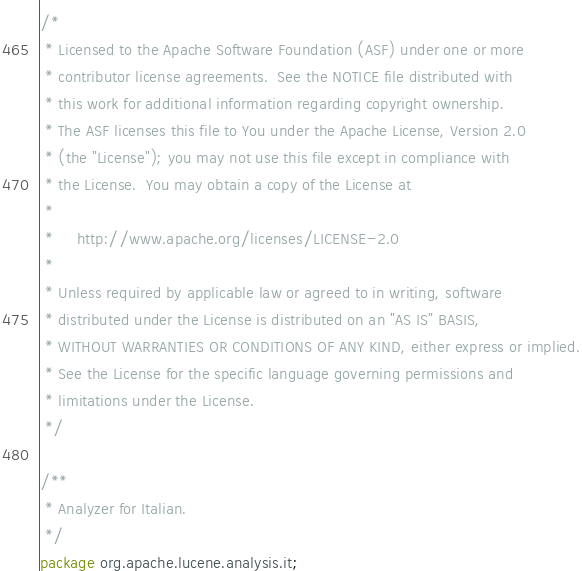<code> <loc_0><loc_0><loc_500><loc_500><_Java_>/*
 * Licensed to the Apache Software Foundation (ASF) under one or more
 * contributor license agreements.  See the NOTICE file distributed with
 * this work for additional information regarding copyright ownership.
 * The ASF licenses this file to You under the Apache License, Version 2.0
 * (the "License"); you may not use this file except in compliance with
 * the License.  You may obtain a copy of the License at
 *
 *     http://www.apache.org/licenses/LICENSE-2.0
 *
 * Unless required by applicable law or agreed to in writing, software
 * distributed under the License is distributed on an "AS IS" BASIS,
 * WITHOUT WARRANTIES OR CONDITIONS OF ANY KIND, either express or implied.
 * See the License for the specific language governing permissions and
 * limitations under the License.
 */

/**
 * Analyzer for Italian.
 */
package org.apache.lucene.analysis.it;
</code> 